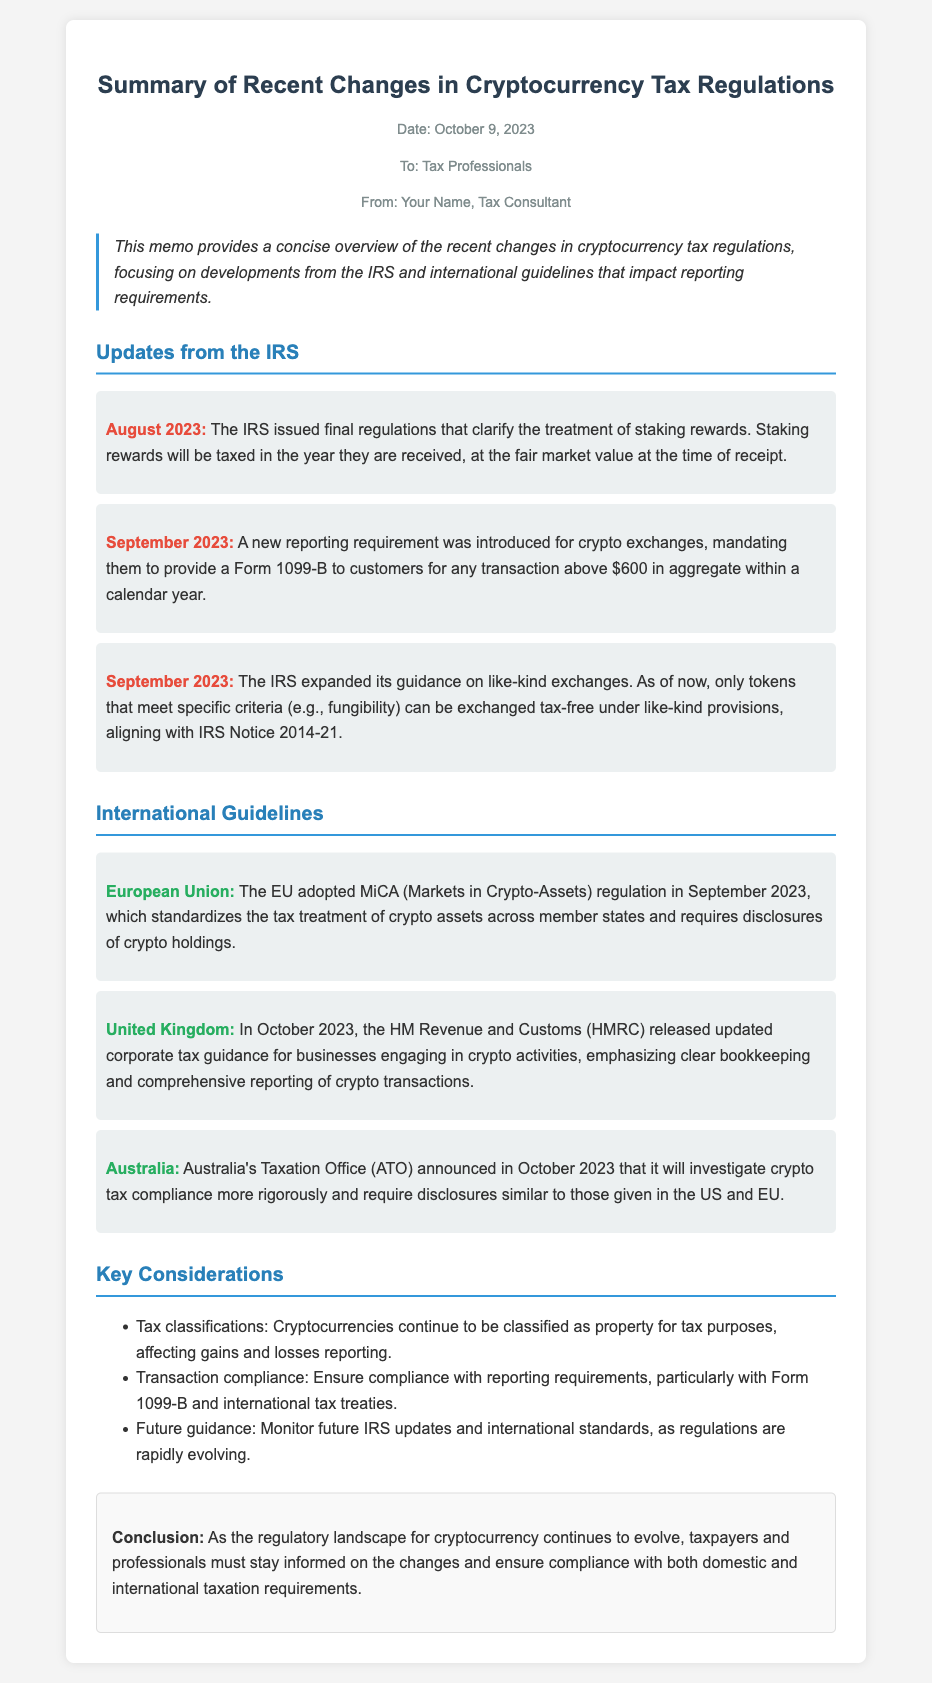What is the date of the memo? The date of the memo is mentioned at the top of the document.
Answer: October 9, 2023 What new reporting requirement was introduced by the IRS? This is specified in the section discussing updates from the IRS, highlighting the new requirement.
Answer: Form 1099-B Which country adopted MiCA regulation? The document specifies a significant update from the European Union regarding cryptocurrency regulation.
Answer: European Union What is the primary theme of the memo? The purpose of the memo is summarized in the introductory paragraph.
Answer: Recent changes in cryptocurrency tax regulations What does the IRS classify cryptocurrencies as for tax purposes? This classification is noted within the key considerations section of the memo.
Answer: Property What guidance did HMRC release in October 2023? The memo indicates the nature of the updated guidance provided by HMRC for businesses.
Answer: Corporate tax guidance What are staking rewards taxed at? The treatment of staking rewards is explained under the IRS updates section of the memo.
Answer: Fair market value What action will Australia's Taxation Office take regarding crypto tax compliance? The memo describes the anticipated actions by the ATO concerning cryptocurrency.
Answer: Investigate compliance more rigorously 